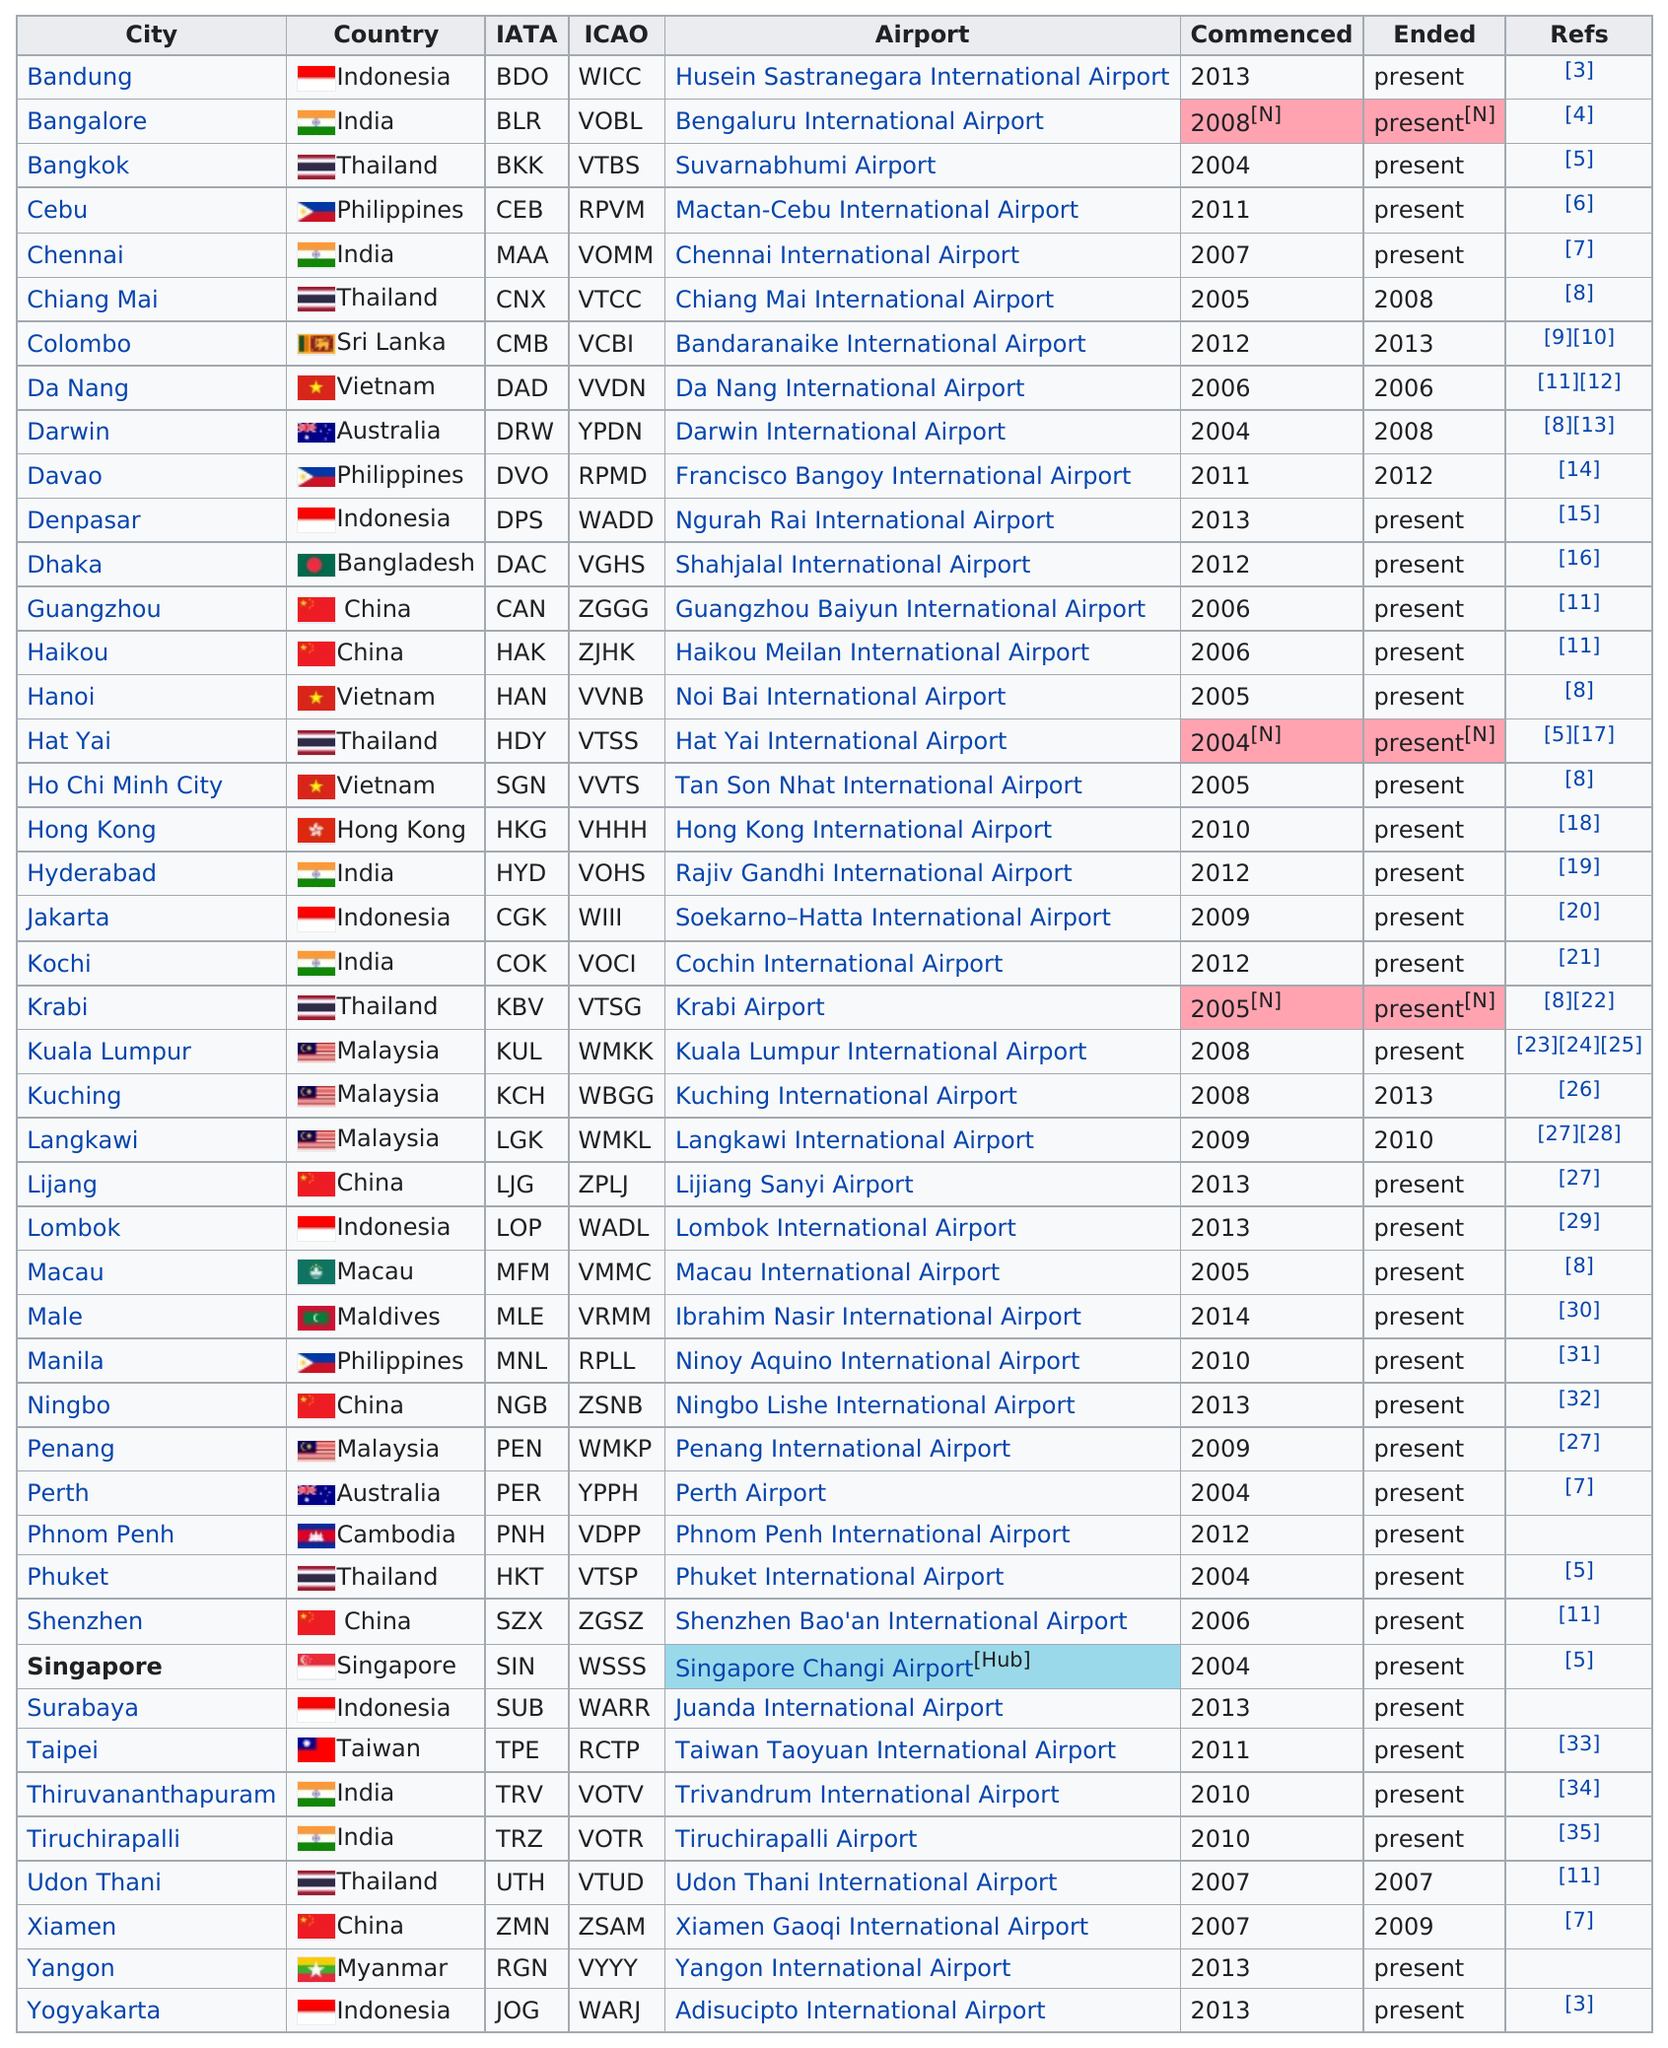Point out several critical features in this image. In the year 2009, Tigerair last offered flights to Xiamen. The next airport listed after Darwin International Airport is Francisco Bangoy International Airport. In the year 2004, Tigerair commenced operations to Perth Airport in Australia, marking the commencement of its flight services to the country. There are 8 instances of the year 2013 listed under the 'Commenced' column. Six of Tigerair's destination cities are located in China. 